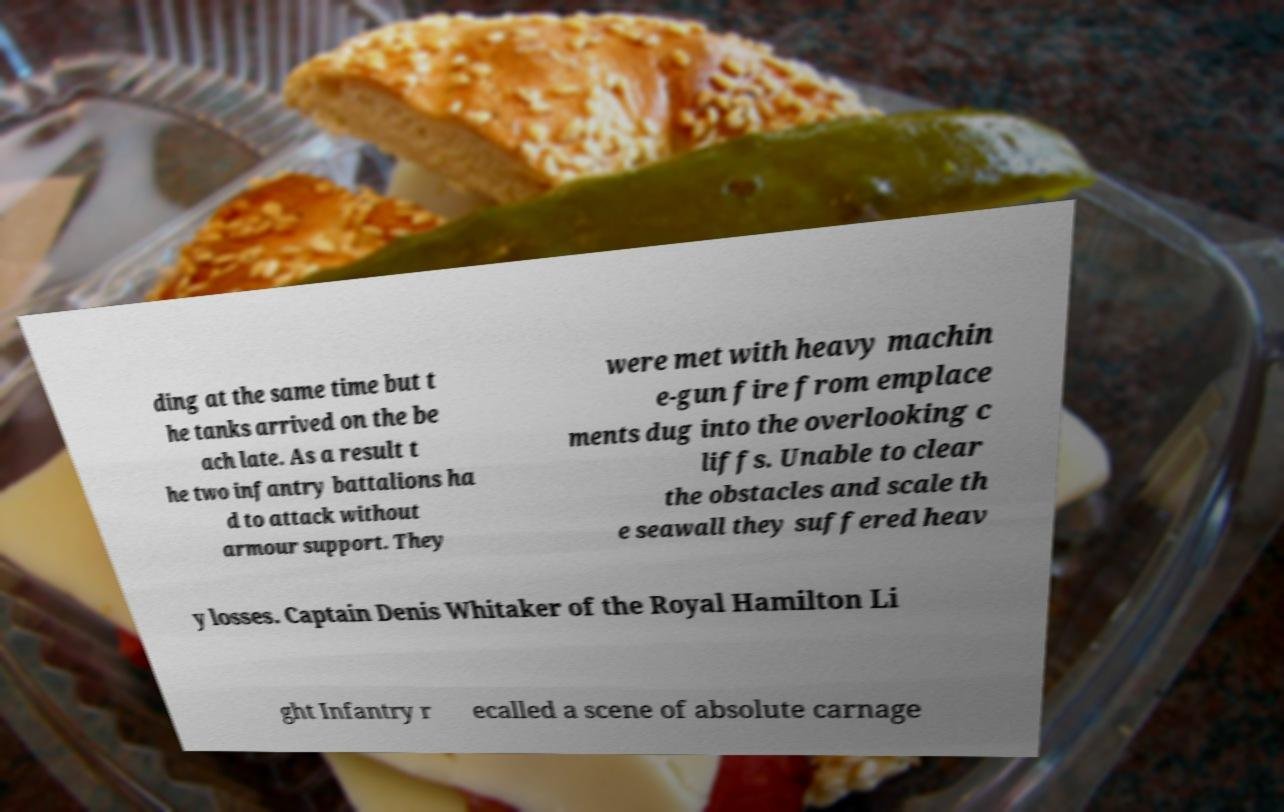Could you assist in decoding the text presented in this image and type it out clearly? ding at the same time but t he tanks arrived on the be ach late. As a result t he two infantry battalions ha d to attack without armour support. They were met with heavy machin e-gun fire from emplace ments dug into the overlooking c liffs. Unable to clear the obstacles and scale th e seawall they suffered heav y losses. Captain Denis Whitaker of the Royal Hamilton Li ght Infantry r ecalled a scene of absolute carnage 